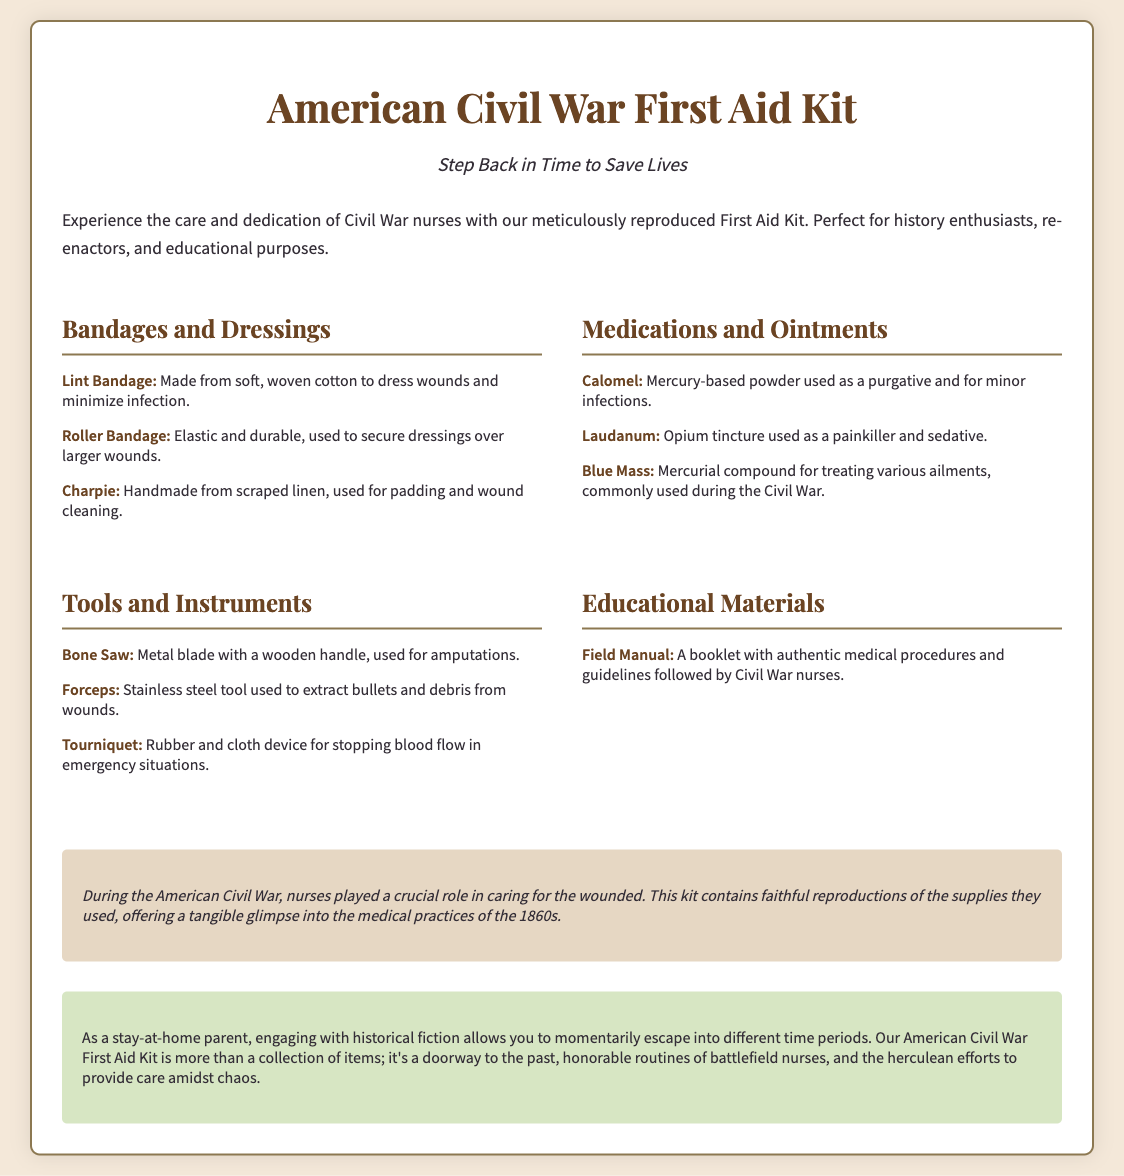What is the title of the product? The title of the product is found at the top of the document.
Answer: American Civil War First Aid Kit What is the phrase used as the tagline? The tagline is a brief phrase that captures the essence of the product.
Answer: Step Back in Time to Save Lives Name one item in the "Bandages and Dressings" category. The items listed under this category are detailed in the document.
Answer: Lint Bandage What type of tool is a "Bone Saw"? The document provides specific descriptions of tools included in the kit.
Answer: Metal blade with a wooden handle Which medication is described as an opium tincture? The document describes medications and their uses, referring specifically to an opium tincture.
Answer: Laudanum How many categories of items are listed in the kit? The number of categories can be tallied from the contents section of the document.
Answer: Four What does the historical context section mention about nurses? This section provides insight into the role of nurses during the Civil War.
Answer: Caring for the wounded What is included as educational material? The educational materials section specifically outlines what is contained.
Answer: Field Manual What is the purpose of the American Civil War First Aid Kit? The purpose is implied through descriptions in multiple sections.
Answer: Experience the care and dedication of Civil War nurses 